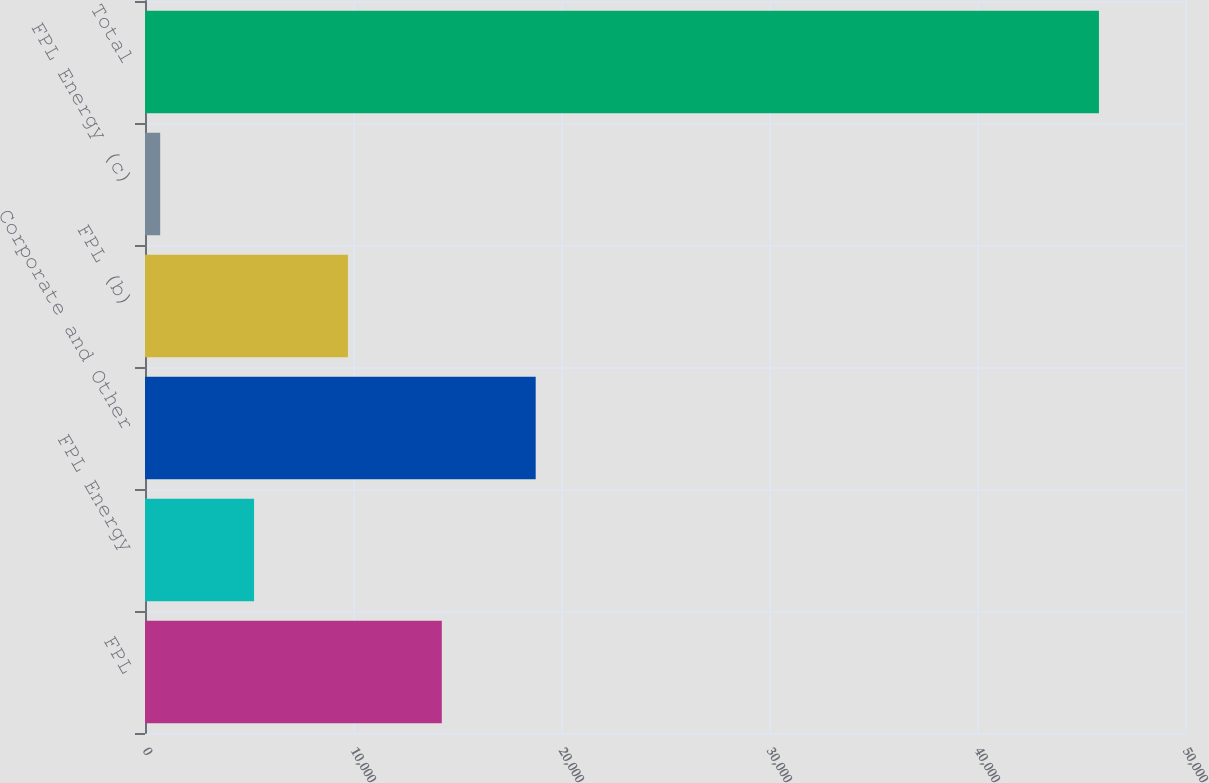<chart> <loc_0><loc_0><loc_500><loc_500><bar_chart><fcel>FPL<fcel>FPL Energy<fcel>Corporate and Other<fcel>FPL (b)<fcel>FPL Energy (c)<fcel>Total<nl><fcel>14269.9<fcel>5243.3<fcel>18783.2<fcel>9756.6<fcel>730<fcel>45863<nl></chart> 